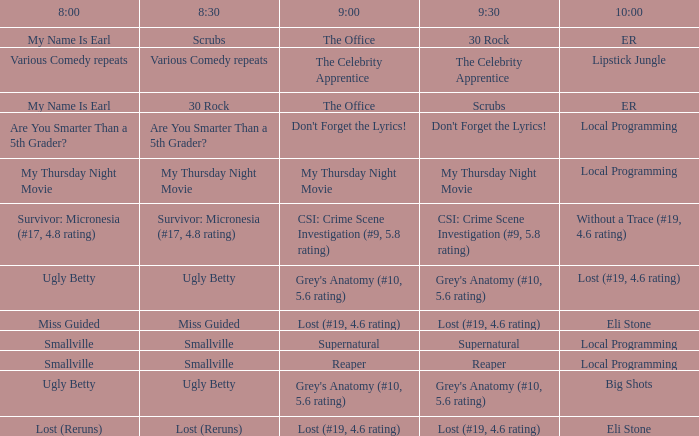What is at 9:30 when at 8:30 it is scrubs? 30 Rock. 